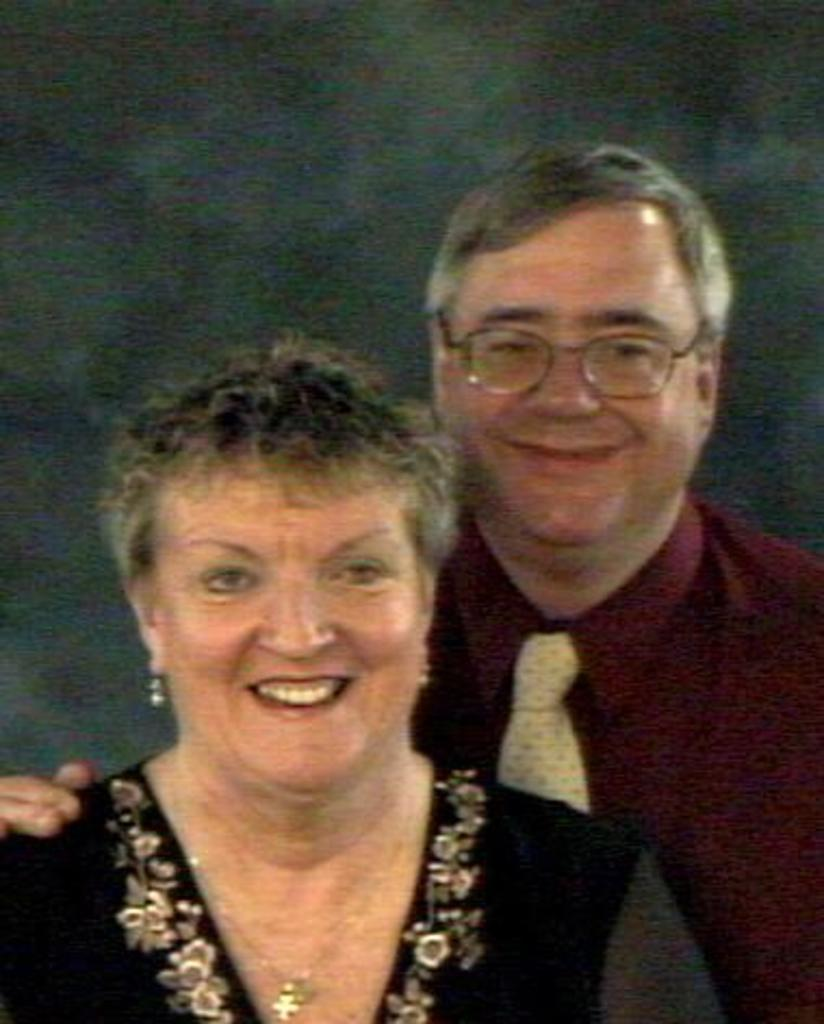Who are the people in the image? There is a man and a woman in the image. What can be seen in the background of the image? There is a wall in the background of the image. How many children are playing with the doll in the image? There are no children or dolls present in the image. 